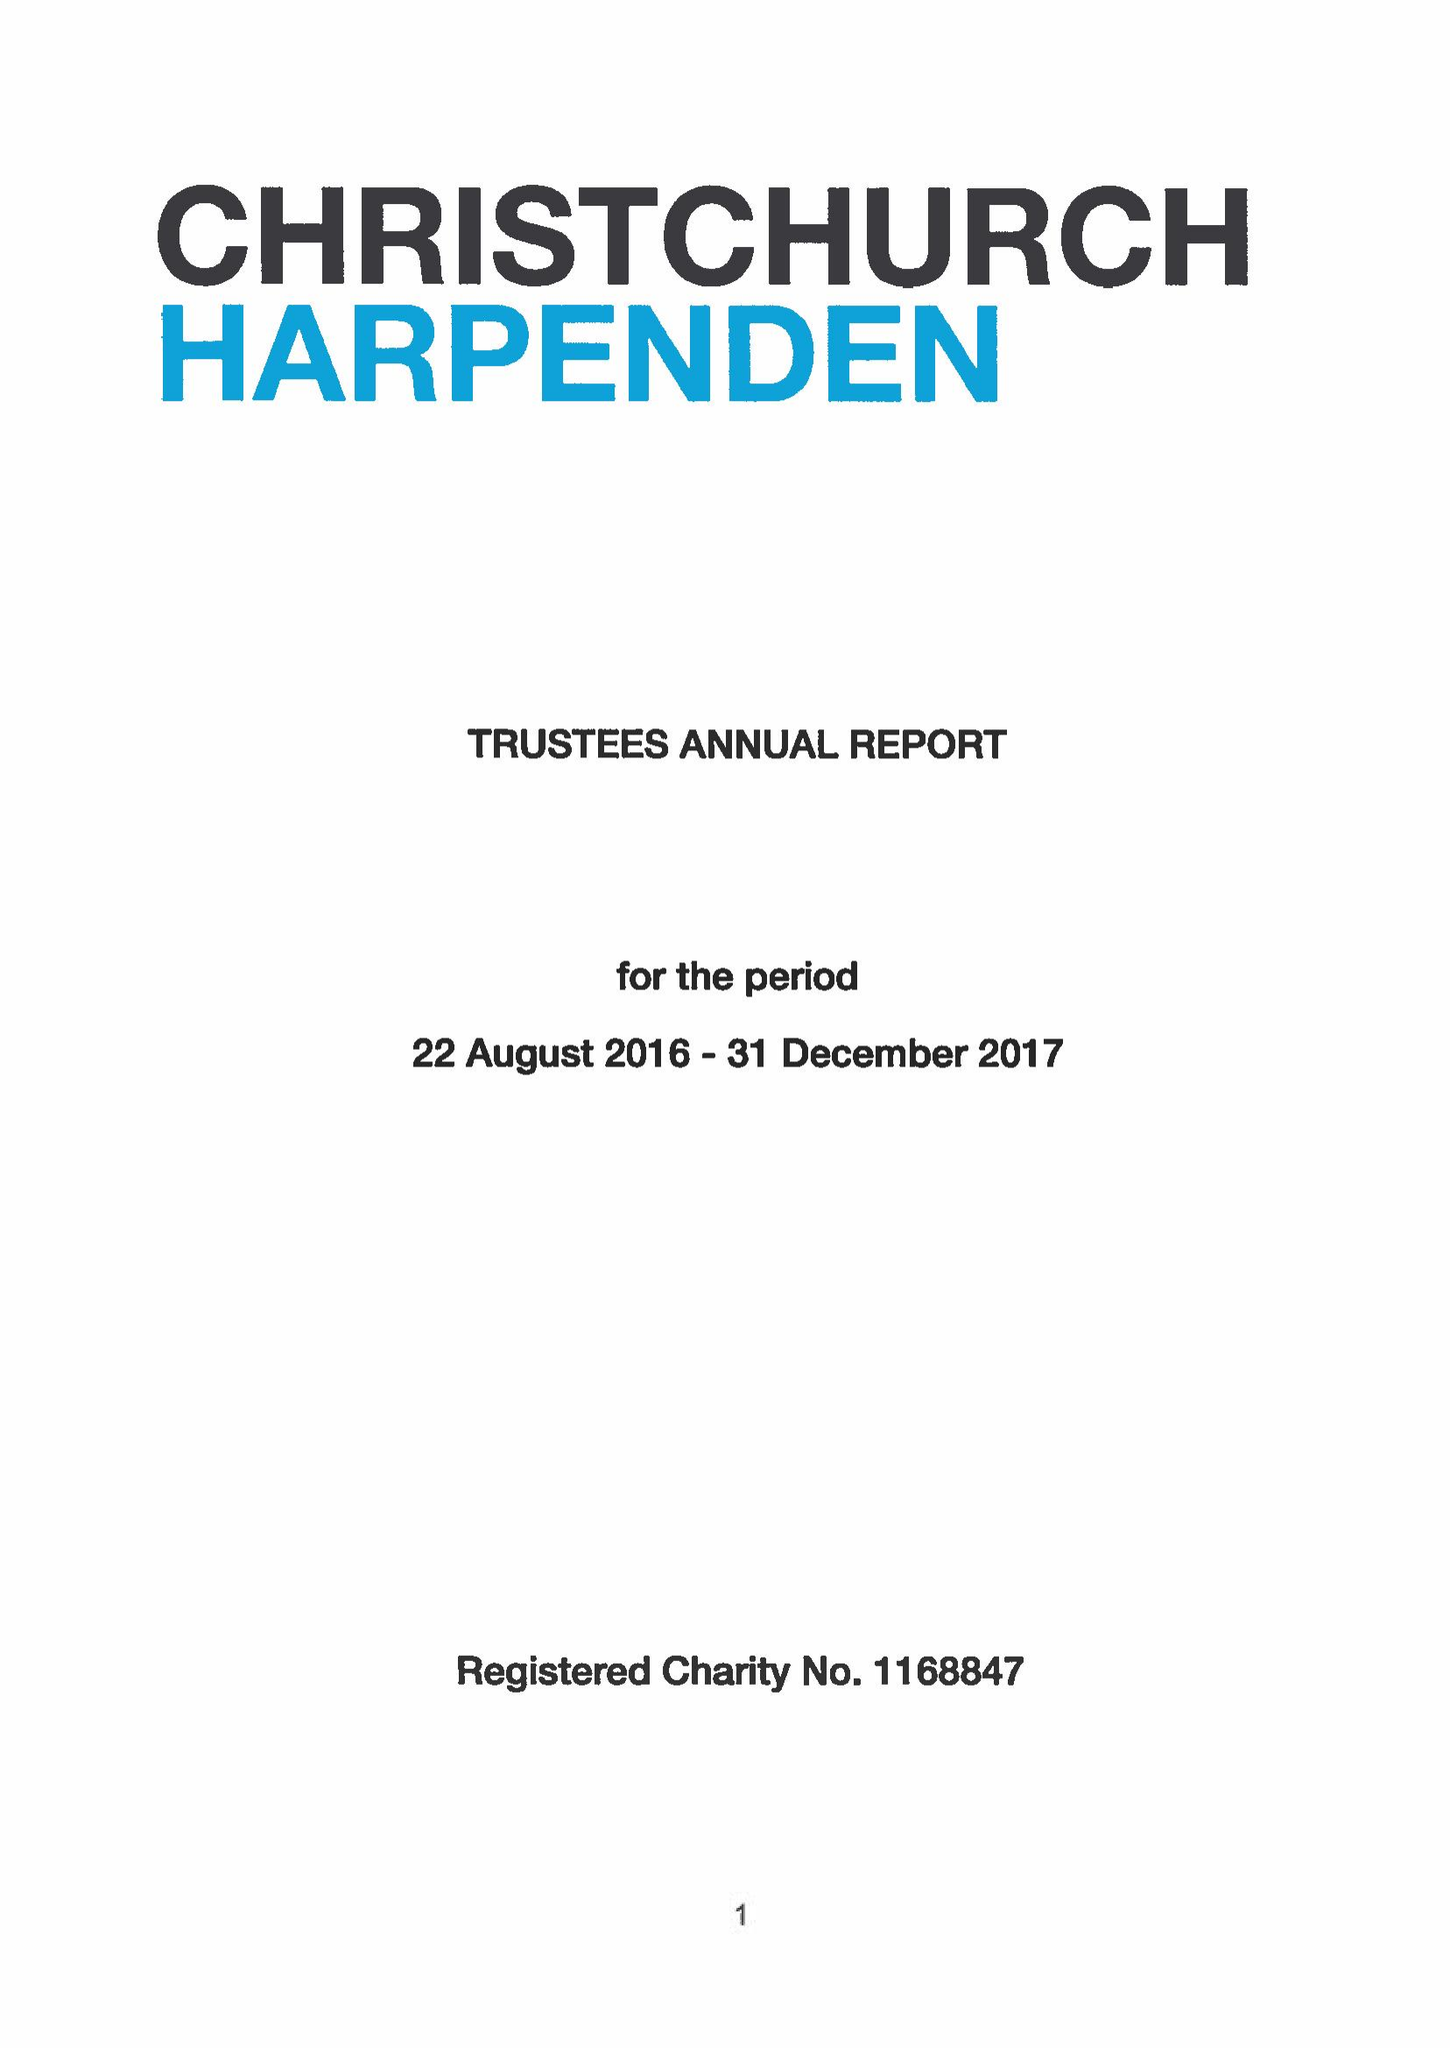What is the value for the address__street_line?
Answer the question using a single word or phrase. 4 VAUGHAN ROAD 